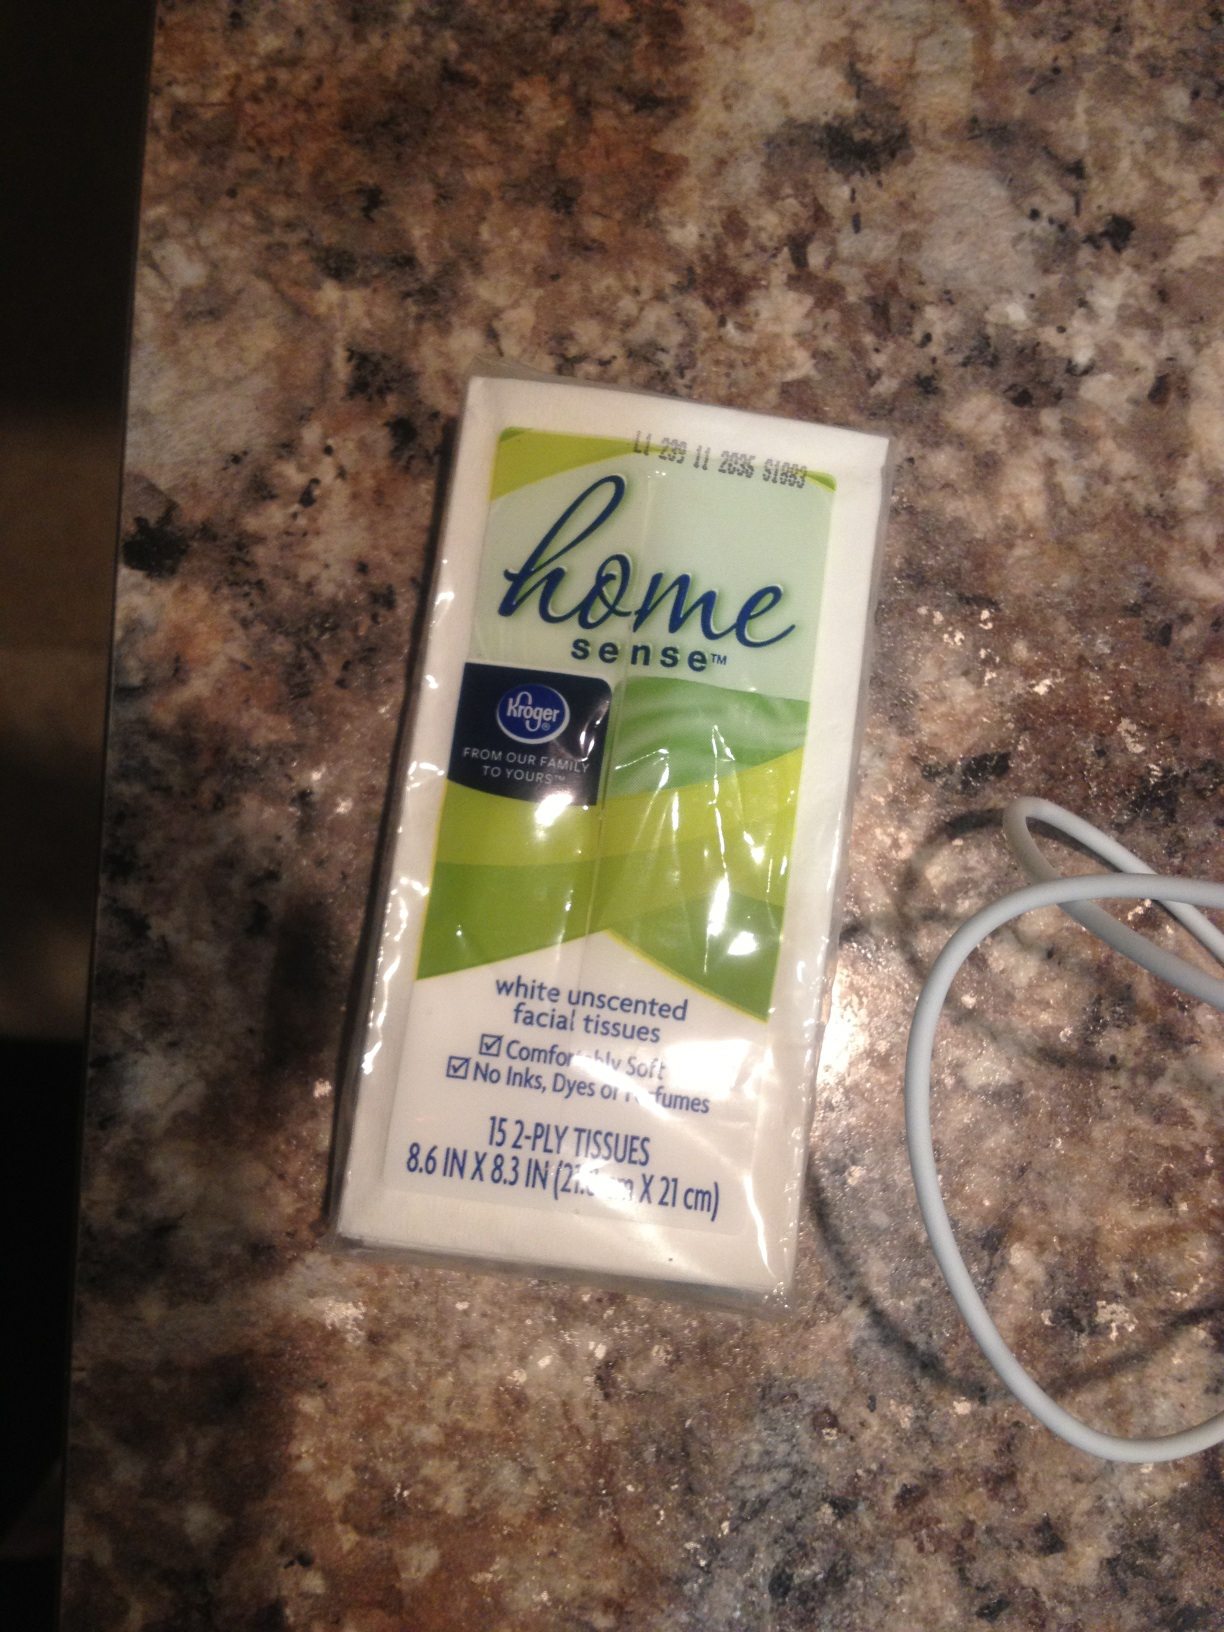Can you create a poem about this pack of tissues? In a small pack of white so neat,
Lie tissues soft, a tidy fleet.
For tears, spills, or a sneeze attack,
They’re always ready, in that pack.
On weary roads and busy days,
They serve us in so many ways.
Unscented, gentle, always there,
To show they really, truly care. 